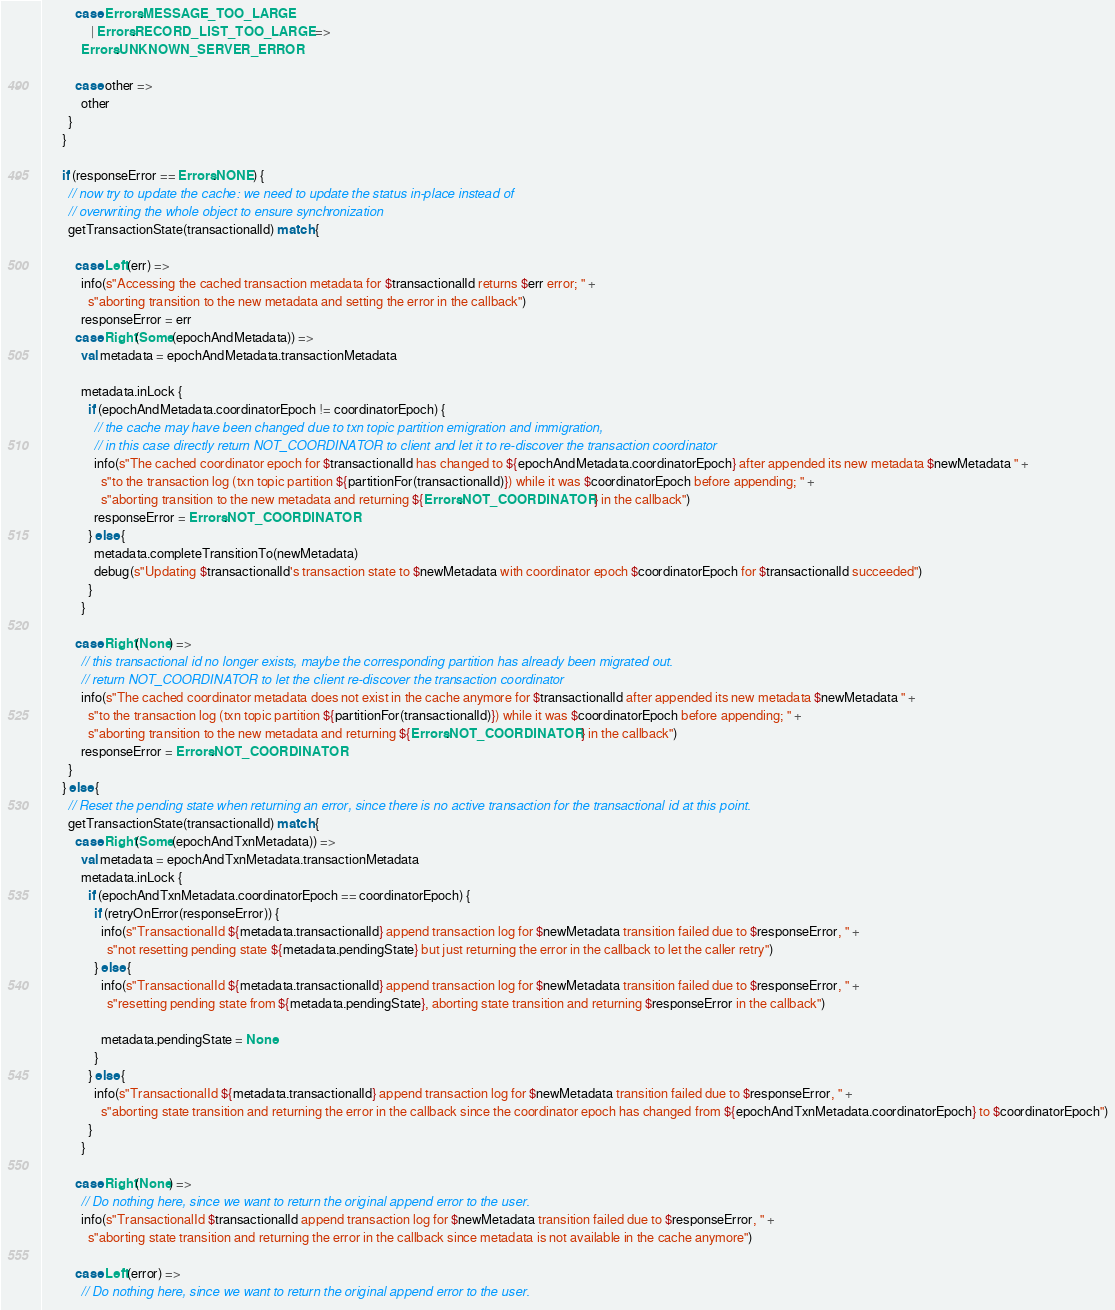Convert code to text. <code><loc_0><loc_0><loc_500><loc_500><_Scala_>
          case Errors.MESSAGE_TOO_LARGE
               | Errors.RECORD_LIST_TOO_LARGE =>
            Errors.UNKNOWN_SERVER_ERROR

          case other =>
            other
        }
      }

      if (responseError == Errors.NONE) {
        // now try to update the cache: we need to update the status in-place instead of
        // overwriting the whole object to ensure synchronization
        getTransactionState(transactionalId) match {

          case Left(err) =>
            info(s"Accessing the cached transaction metadata for $transactionalId returns $err error; " +
              s"aborting transition to the new metadata and setting the error in the callback")
            responseError = err
          case Right(Some(epochAndMetadata)) =>
            val metadata = epochAndMetadata.transactionMetadata

            metadata.inLock {
              if (epochAndMetadata.coordinatorEpoch != coordinatorEpoch) {
                // the cache may have been changed due to txn topic partition emigration and immigration,
                // in this case directly return NOT_COORDINATOR to client and let it to re-discover the transaction coordinator
                info(s"The cached coordinator epoch for $transactionalId has changed to ${epochAndMetadata.coordinatorEpoch} after appended its new metadata $newMetadata " +
                  s"to the transaction log (txn topic partition ${partitionFor(transactionalId)}) while it was $coordinatorEpoch before appending; " +
                  s"aborting transition to the new metadata and returning ${Errors.NOT_COORDINATOR} in the callback")
                responseError = Errors.NOT_COORDINATOR
              } else {
                metadata.completeTransitionTo(newMetadata)
                debug(s"Updating $transactionalId's transaction state to $newMetadata with coordinator epoch $coordinatorEpoch for $transactionalId succeeded")
              }
            }

          case Right(None) =>
            // this transactional id no longer exists, maybe the corresponding partition has already been migrated out.
            // return NOT_COORDINATOR to let the client re-discover the transaction coordinator
            info(s"The cached coordinator metadata does not exist in the cache anymore for $transactionalId after appended its new metadata $newMetadata " +
              s"to the transaction log (txn topic partition ${partitionFor(transactionalId)}) while it was $coordinatorEpoch before appending; " +
              s"aborting transition to the new metadata and returning ${Errors.NOT_COORDINATOR} in the callback")
            responseError = Errors.NOT_COORDINATOR
        }
      } else {
        // Reset the pending state when returning an error, since there is no active transaction for the transactional id at this point.
        getTransactionState(transactionalId) match {
          case Right(Some(epochAndTxnMetadata)) =>
            val metadata = epochAndTxnMetadata.transactionMetadata
            metadata.inLock {
              if (epochAndTxnMetadata.coordinatorEpoch == coordinatorEpoch) {
                if (retryOnError(responseError)) {
                  info(s"TransactionalId ${metadata.transactionalId} append transaction log for $newMetadata transition failed due to $responseError, " +
                    s"not resetting pending state ${metadata.pendingState} but just returning the error in the callback to let the caller retry")
                } else {
                  info(s"TransactionalId ${metadata.transactionalId} append transaction log for $newMetadata transition failed due to $responseError, " +
                    s"resetting pending state from ${metadata.pendingState}, aborting state transition and returning $responseError in the callback")

                  metadata.pendingState = None
                }
              } else {
                info(s"TransactionalId ${metadata.transactionalId} append transaction log for $newMetadata transition failed due to $responseError, " +
                  s"aborting state transition and returning the error in the callback since the coordinator epoch has changed from ${epochAndTxnMetadata.coordinatorEpoch} to $coordinatorEpoch")
              }
            }

          case Right(None) =>
            // Do nothing here, since we want to return the original append error to the user.
            info(s"TransactionalId $transactionalId append transaction log for $newMetadata transition failed due to $responseError, " +
              s"aborting state transition and returning the error in the callback since metadata is not available in the cache anymore")

          case Left(error) =>
            // Do nothing here, since we want to return the original append error to the user.</code> 